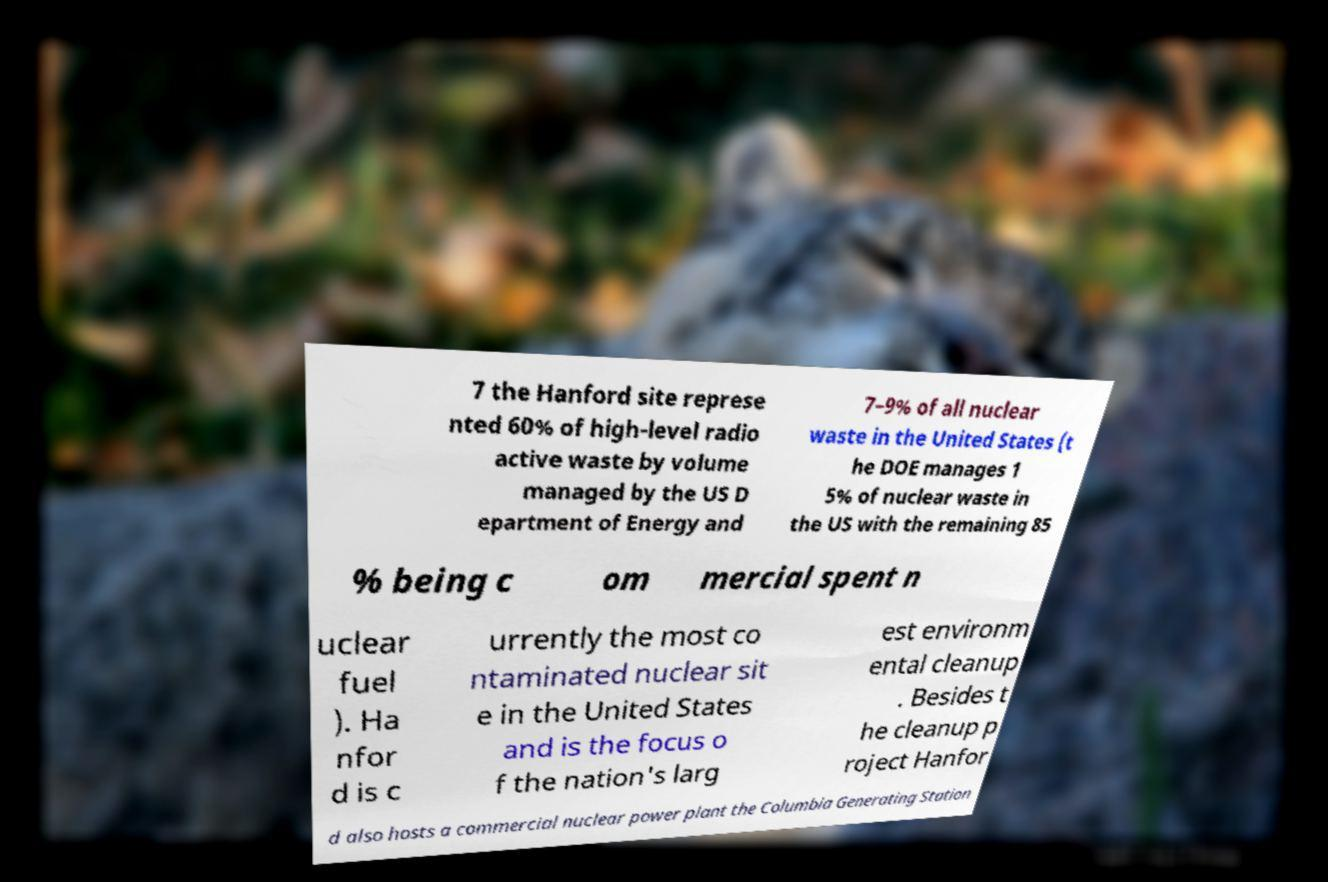Could you assist in decoding the text presented in this image and type it out clearly? 7 the Hanford site represe nted 60% of high-level radio active waste by volume managed by the US D epartment of Energy and 7–9% of all nuclear waste in the United States (t he DOE manages 1 5% of nuclear waste in the US with the remaining 85 % being c om mercial spent n uclear fuel ). Ha nfor d is c urrently the most co ntaminated nuclear sit e in the United States and is the focus o f the nation's larg est environm ental cleanup . Besides t he cleanup p roject Hanfor d also hosts a commercial nuclear power plant the Columbia Generating Station 